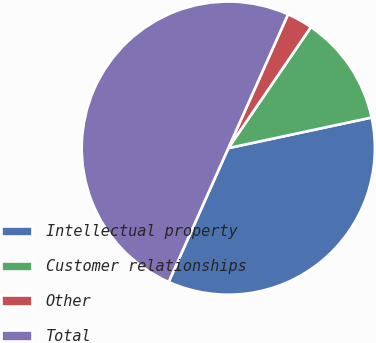<chart> <loc_0><loc_0><loc_500><loc_500><pie_chart><fcel>Intellectual property<fcel>Customer relationships<fcel>Other<fcel>Total<nl><fcel>35.02%<fcel>12.12%<fcel>2.85%<fcel>50.0%<nl></chart> 